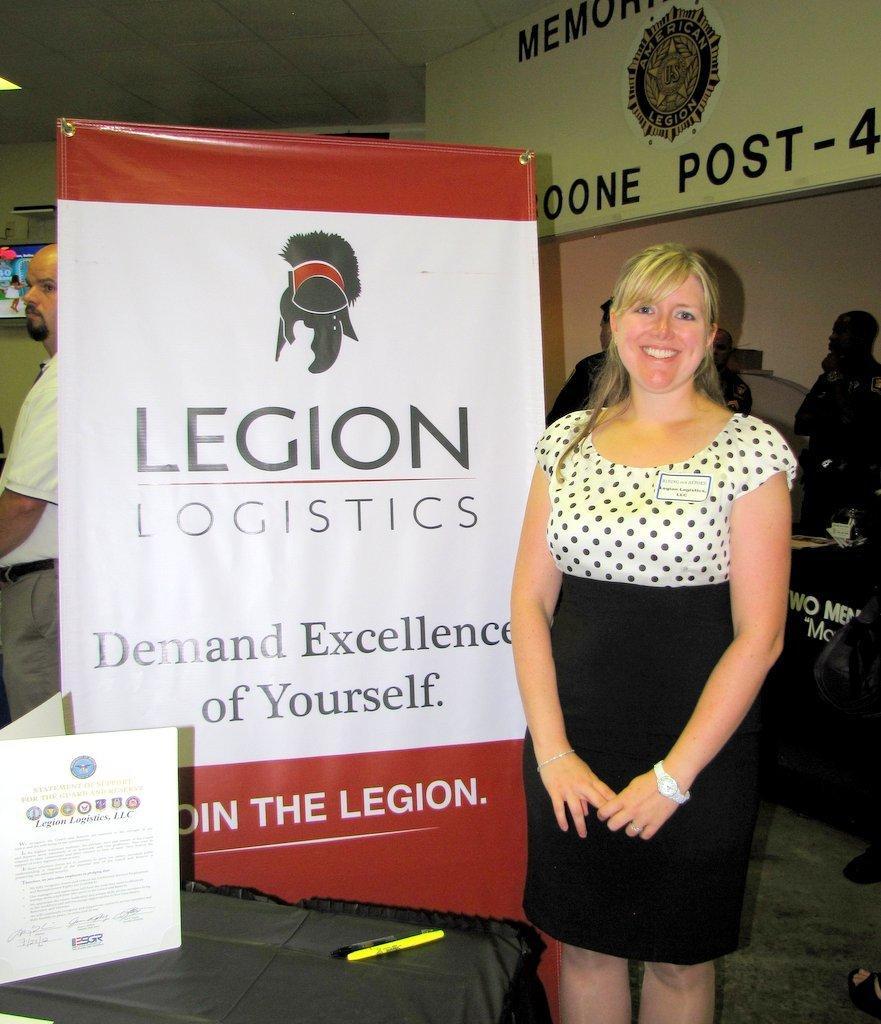Could you give a brief overview of what you see in this image? In this image I can see few people are standing. I can also see few boards and I can see something is written at few places. I can also see smile on her face and here I can see few things. 